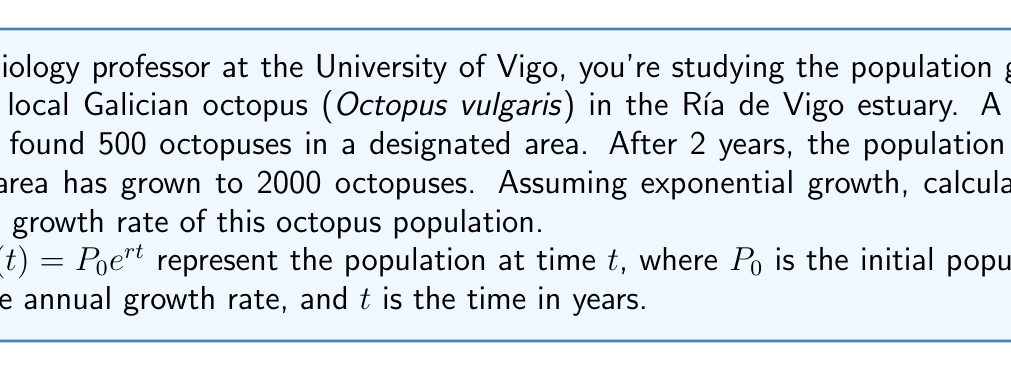Can you solve this math problem? To solve this problem, we'll use the exponential growth formula:

$P(t) = P_0 e^{rt}$

Given:
- Initial population, $P_0 = 500$
- Final population after 2 years, $P(2) = 2000$
- Time period, $t = 2$ years

Step 1: Substitute the known values into the formula:
$2000 = 500 e^{r(2)}$

Step 2: Divide both sides by 500:
$4 = e^{2r}$

Step 3: Take the natural logarithm of both sides:
$\ln(4) = \ln(e^{2r})$
$\ln(4) = 2r$

Step 4: Solve for $r$:
$r = \frac{\ln(4)}{2}$

Step 5: Calculate the value of $r$:
$r = \frac{\ln(4)}{2} \approx 0.6931$

Step 6: Convert to percentage:
Annual growth rate $= 0.6931 \times 100\% \approx 69.31\%$
Answer: The annual growth rate of the Galician octopus population in the Ría de Vigo estuary is approximately 69.31%. 